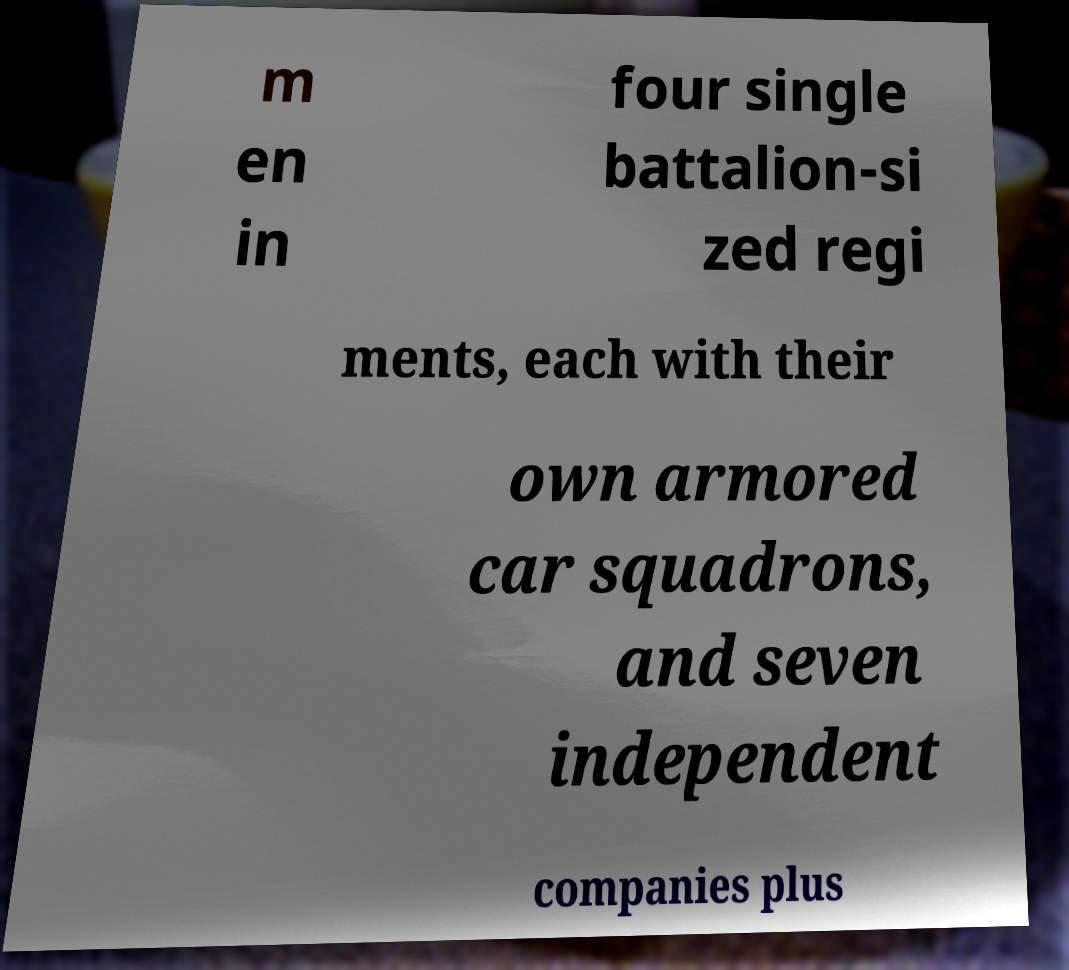Can you accurately transcribe the text from the provided image for me? m en in four single battalion-si zed regi ments, each with their own armored car squadrons, and seven independent companies plus 